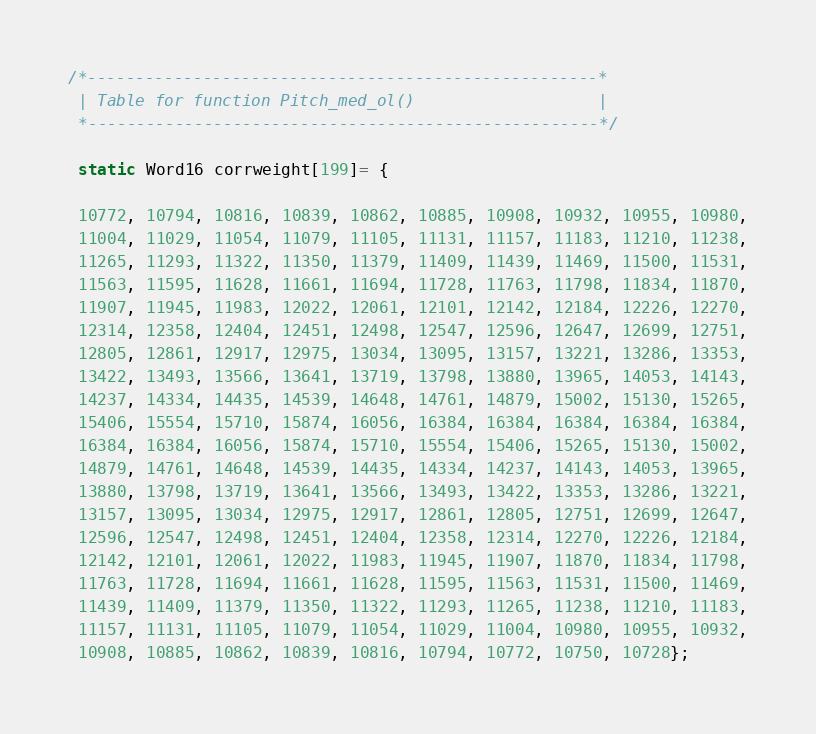Convert code to text. <code><loc_0><loc_0><loc_500><loc_500><_SQL_>/*-----------------------------------------------------*
 | Table for function Pitch_med_ol()				   |
 *-----------------------------------------------------*/

 static Word16 corrweight[199]= {

 10772, 10794, 10816, 10839, 10862, 10885, 10908, 10932, 10955, 10980,
 11004, 11029, 11054, 11079, 11105, 11131, 11157, 11183, 11210, 11238,
 11265, 11293, 11322, 11350, 11379, 11409, 11439, 11469, 11500, 11531,
 11563, 11595, 11628, 11661, 11694, 11728, 11763, 11798, 11834, 11870,
 11907, 11945, 11983, 12022, 12061, 12101, 12142, 12184, 12226, 12270,
 12314, 12358, 12404, 12451, 12498, 12547, 12596, 12647, 12699, 12751,
 12805, 12861, 12917, 12975, 13034, 13095, 13157, 13221, 13286, 13353,
 13422, 13493, 13566, 13641, 13719, 13798, 13880, 13965, 14053, 14143,
 14237, 14334, 14435, 14539, 14648, 14761, 14879, 15002, 15130, 15265,
 15406, 15554, 15710, 15874, 16056, 16384, 16384, 16384, 16384, 16384,
 16384, 16384, 16056, 15874, 15710, 15554, 15406, 15265, 15130, 15002,
 14879, 14761, 14648, 14539, 14435, 14334, 14237, 14143, 14053, 13965,
 13880, 13798, 13719, 13641, 13566, 13493, 13422, 13353, 13286, 13221,
 13157, 13095, 13034, 12975, 12917, 12861, 12805, 12751, 12699, 12647,
 12596, 12547, 12498, 12451, 12404, 12358, 12314, 12270, 12226, 12184,
 12142, 12101, 12061, 12022, 11983, 11945, 11907, 11870, 11834, 11798,
 11763, 11728, 11694, 11661, 11628, 11595, 11563, 11531, 11500, 11469,
 11439, 11409, 11379, 11350, 11322, 11293, 11265, 11238, 11210, 11183,
 11157, 11131, 11105, 11079, 11054, 11029, 11004, 10980, 10955, 10932,
 10908, 10885, 10862, 10839, 10816, 10794, 10772, 10750, 10728};
</code> 